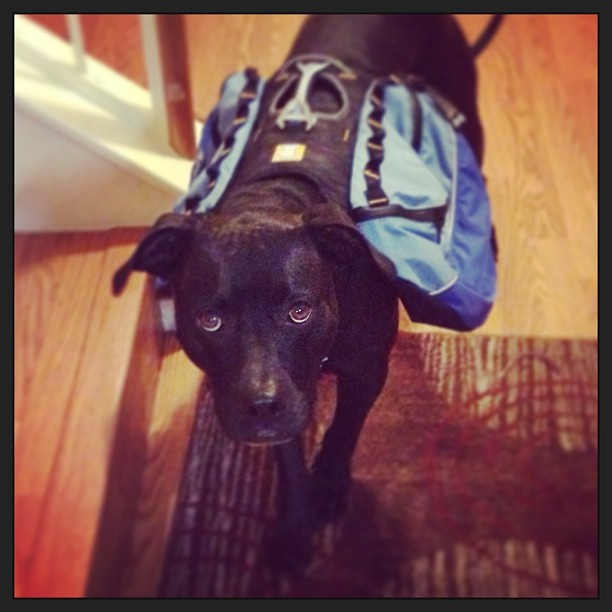Describe the objects in this image and their specific colors. I can see a dog in black and purple tones in this image. 